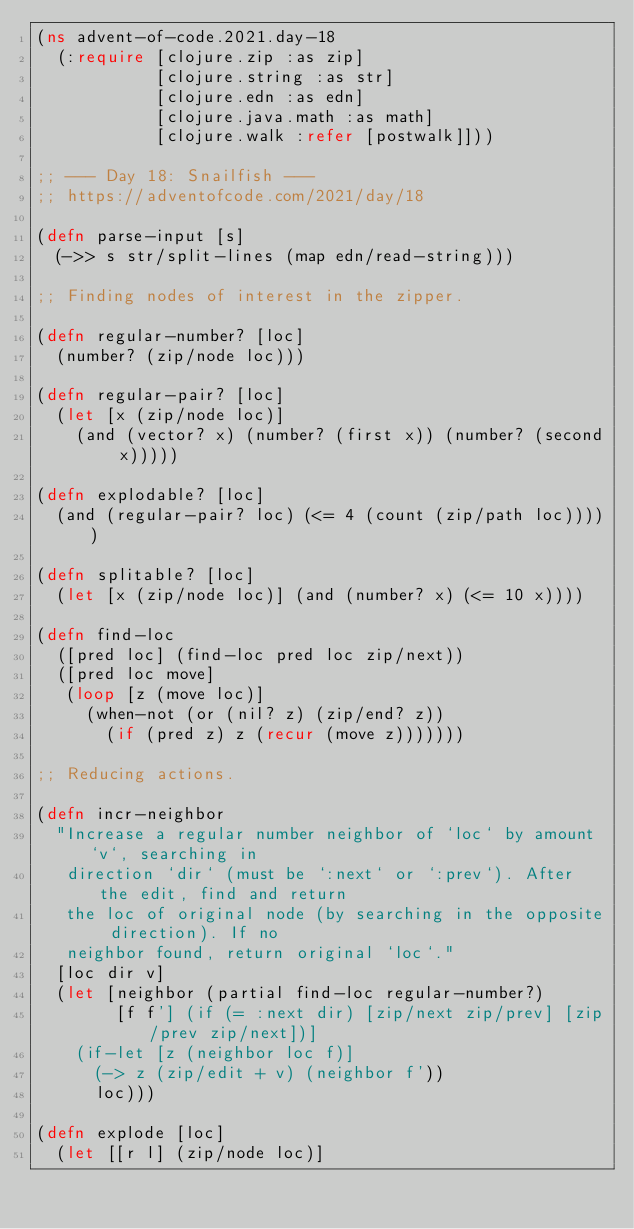<code> <loc_0><loc_0><loc_500><loc_500><_Clojure_>(ns advent-of-code.2021.day-18
  (:require [clojure.zip :as zip]
            [clojure.string :as str]
            [clojure.edn :as edn]
            [clojure.java.math :as math]
            [clojure.walk :refer [postwalk]]))

;; --- Day 18: Snailfish ---
;; https://adventofcode.com/2021/day/18

(defn parse-input [s]
  (->> s str/split-lines (map edn/read-string)))

;; Finding nodes of interest in the zipper.

(defn regular-number? [loc]
  (number? (zip/node loc)))

(defn regular-pair? [loc]
  (let [x (zip/node loc)]
    (and (vector? x) (number? (first x)) (number? (second x)))))

(defn explodable? [loc]
  (and (regular-pair? loc) (<= 4 (count (zip/path loc)))))

(defn splitable? [loc]
  (let [x (zip/node loc)] (and (number? x) (<= 10 x))))

(defn find-loc
  ([pred loc] (find-loc pred loc zip/next))
  ([pred loc move]
   (loop [z (move loc)]
     (when-not (or (nil? z) (zip/end? z))
       (if (pred z) z (recur (move z)))))))

;; Reducing actions.

(defn incr-neighbor
  "Increase a regular number neighbor of `loc` by amount `v`, searching in
   direction `dir` (must be `:next` or `:prev`). After the edit, find and return
   the loc of original node (by searching in the opposite direction). If no
   neighbor found, return original `loc`."
  [loc dir v]
  (let [neighbor (partial find-loc regular-number?)
        [f f'] (if (= :next dir) [zip/next zip/prev] [zip/prev zip/next])]
    (if-let [z (neighbor loc f)]
      (-> z (zip/edit + v) (neighbor f'))
      loc)))

(defn explode [loc]
  (let [[r l] (zip/node loc)]</code> 